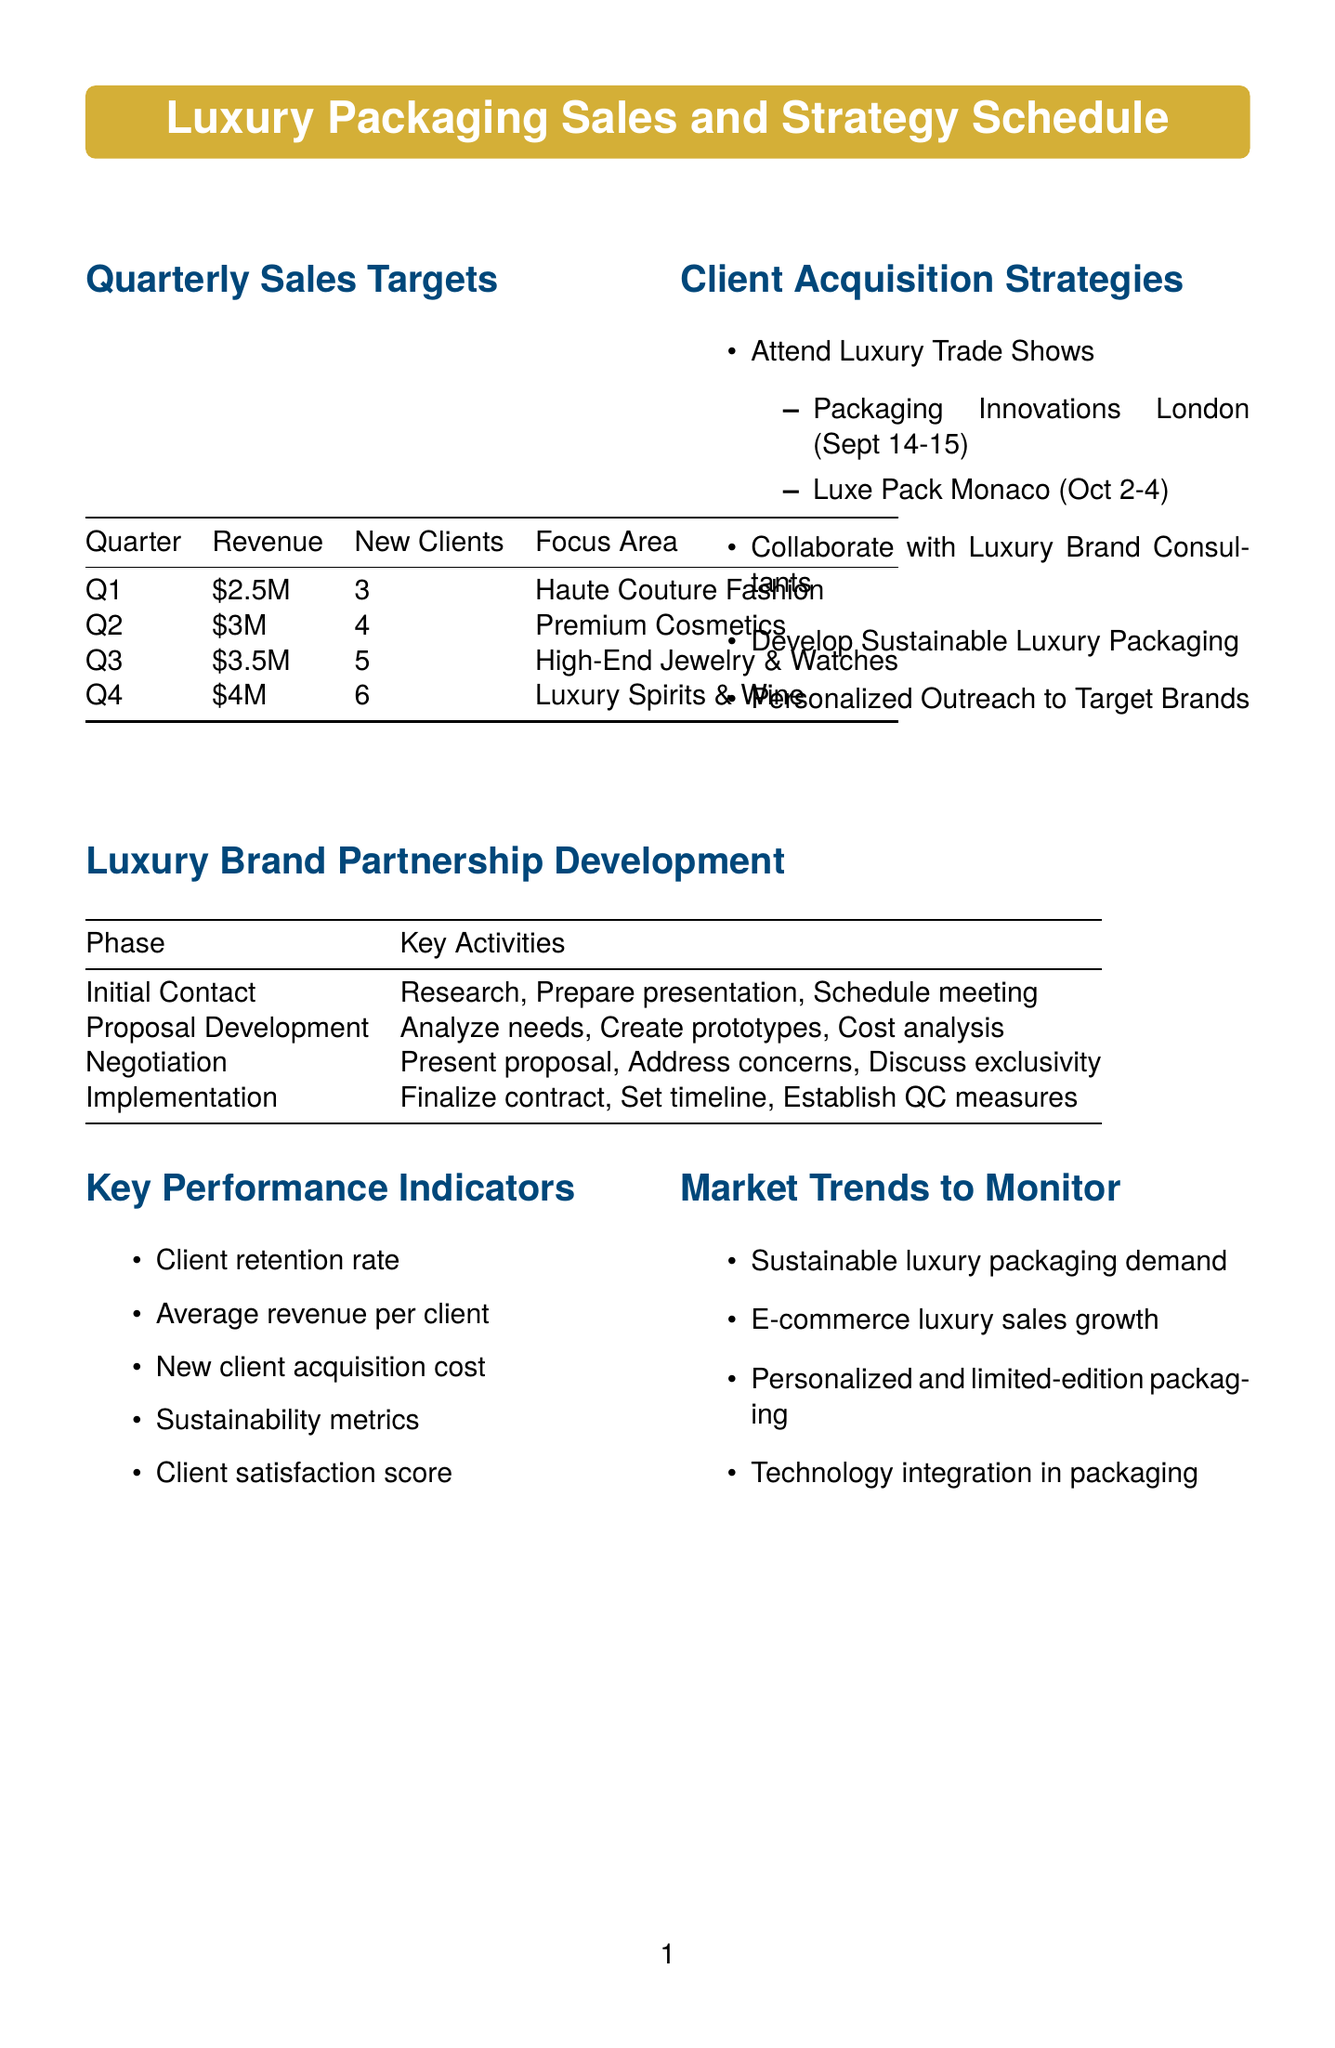What is the revenue target for Q3? The revenue target for Q3 is specified in the document, which states it is $3.5 million.
Answer: $3.5 million How many new clients are targeted in Q2? The document lists the new clients target for each quarter, indicating that Q2 aims for 4 new clients.
Answer: 4 What is the focus area for Q1? The focus area for Q1 is detailed in the quarterly sales targets, which is Haute Couture Fashion Houses.
Answer: Haute Couture Fashion Houses What strategy involves attending trade shows? The document clearly outlines a strategy to "Attend Luxury Trade Shows" as part of the client acquisition strategies.
Answer: Attend Luxury Trade Shows Which brand group is targeted for personalized outreach? The document mentions specific target brands for outreach, including LVMH Group.
Answer: LVMH Group What is the first phase in luxury brand partnership development? The luxury brand partnership development phases are listed, and the first phase is Initial Contact.
Answer: Initial Contact What is one of the key performance indicators? The document provides multiple key performance indicators, one of which is Client retention rate.
Answer: Client retention rate When is the Luxe Pack Monaco event? The document states the dates for the Luxe Pack Monaco event, which takes place from October 2-4, 2023.
Answer: October 2-4, 2023 How many sustainable packaging initiatives are mentioned? The document lists three specific initiatives for sustainable luxury packaging solutions.
Answer: 3 